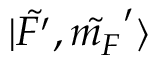Convert formula to latex. <formula><loc_0><loc_0><loc_500><loc_500>| \tilde { F ^ { \prime } } , \tilde { m _ { F } } ^ { \prime } \rangle</formula> 